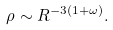<formula> <loc_0><loc_0><loc_500><loc_500>\rho \sim R ^ { - 3 ( 1 + \omega ) } .</formula> 